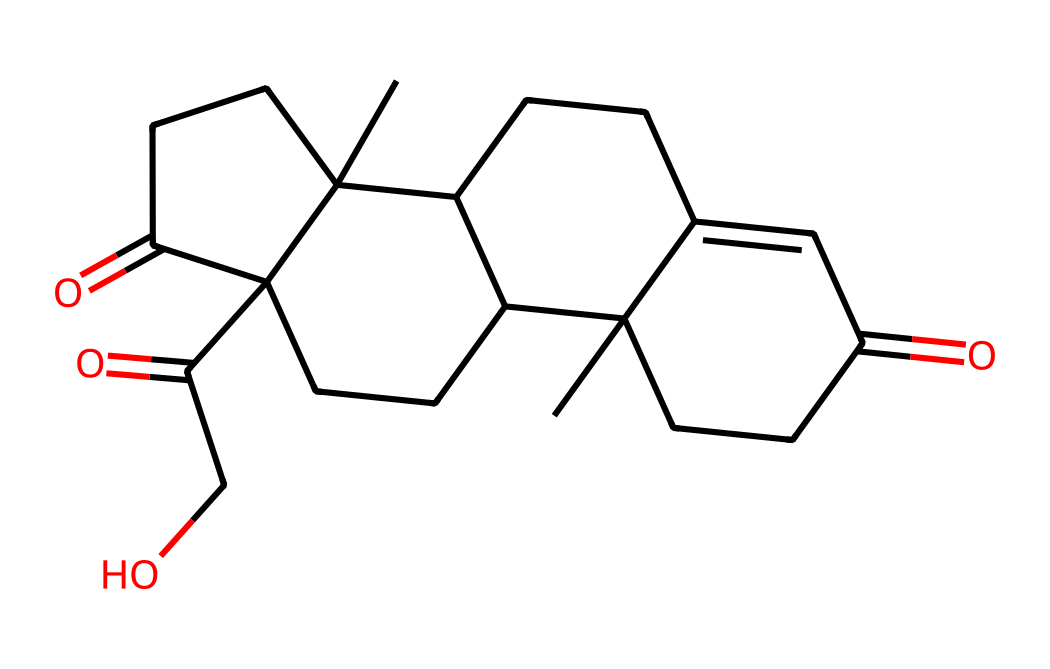How many carbon atoms are in cortisol? By analyzing the SMILES representation, you can count the carbon (C) symbols. In this structure, there are 21 instances of the carbon atom.
Answer: 21 What is the molecular weight of cortisol? To determine the molecular weight, you need to sum the weights of all atoms present in the structure. Based on the atomic weights (C=12.01, H=1.008, O=16.00), the total is approximately 362.46 g/mol.
Answer: 362.46 g/mol Is cortisol a steroid? Cortisol has a characteristic four-ring core structure common in steroids. The presence of this structure indicates that it is indeed a steroid hormone.
Answer: Yes What functional groups are present in cortisol? By examining the SMILES structure, it can be determined that cortisol contains ketone (=O) and hydroxyl (-OH) functional groups. These groups influence its biological activity.
Answer: Ketone and hydroxyl What type of hormone is cortisol? Cortisol is classified as a glucocorticoid hormone, which is primarily involved in glucose metabolism and stress response.
Answer: Glucocorticoid How many rings are present in the structure of cortisol? The visual representation suggests that there are four fused carbon rings in the structure of cortisol, which is typical for steroid hormones.
Answer: 4 What role does cortisol play in the body? Cortisol is primarily known for its role in the stress response and regulating metabolism, inflammation, and immune response.
Answer: Stress response and metabolism regulation 